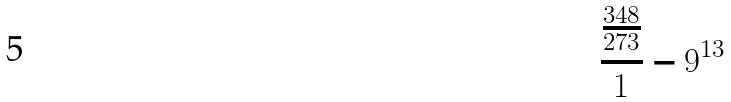<formula> <loc_0><loc_0><loc_500><loc_500>\frac { \frac { 3 4 8 } { 2 7 3 } } { 1 } - 9 ^ { 1 3 }</formula> 